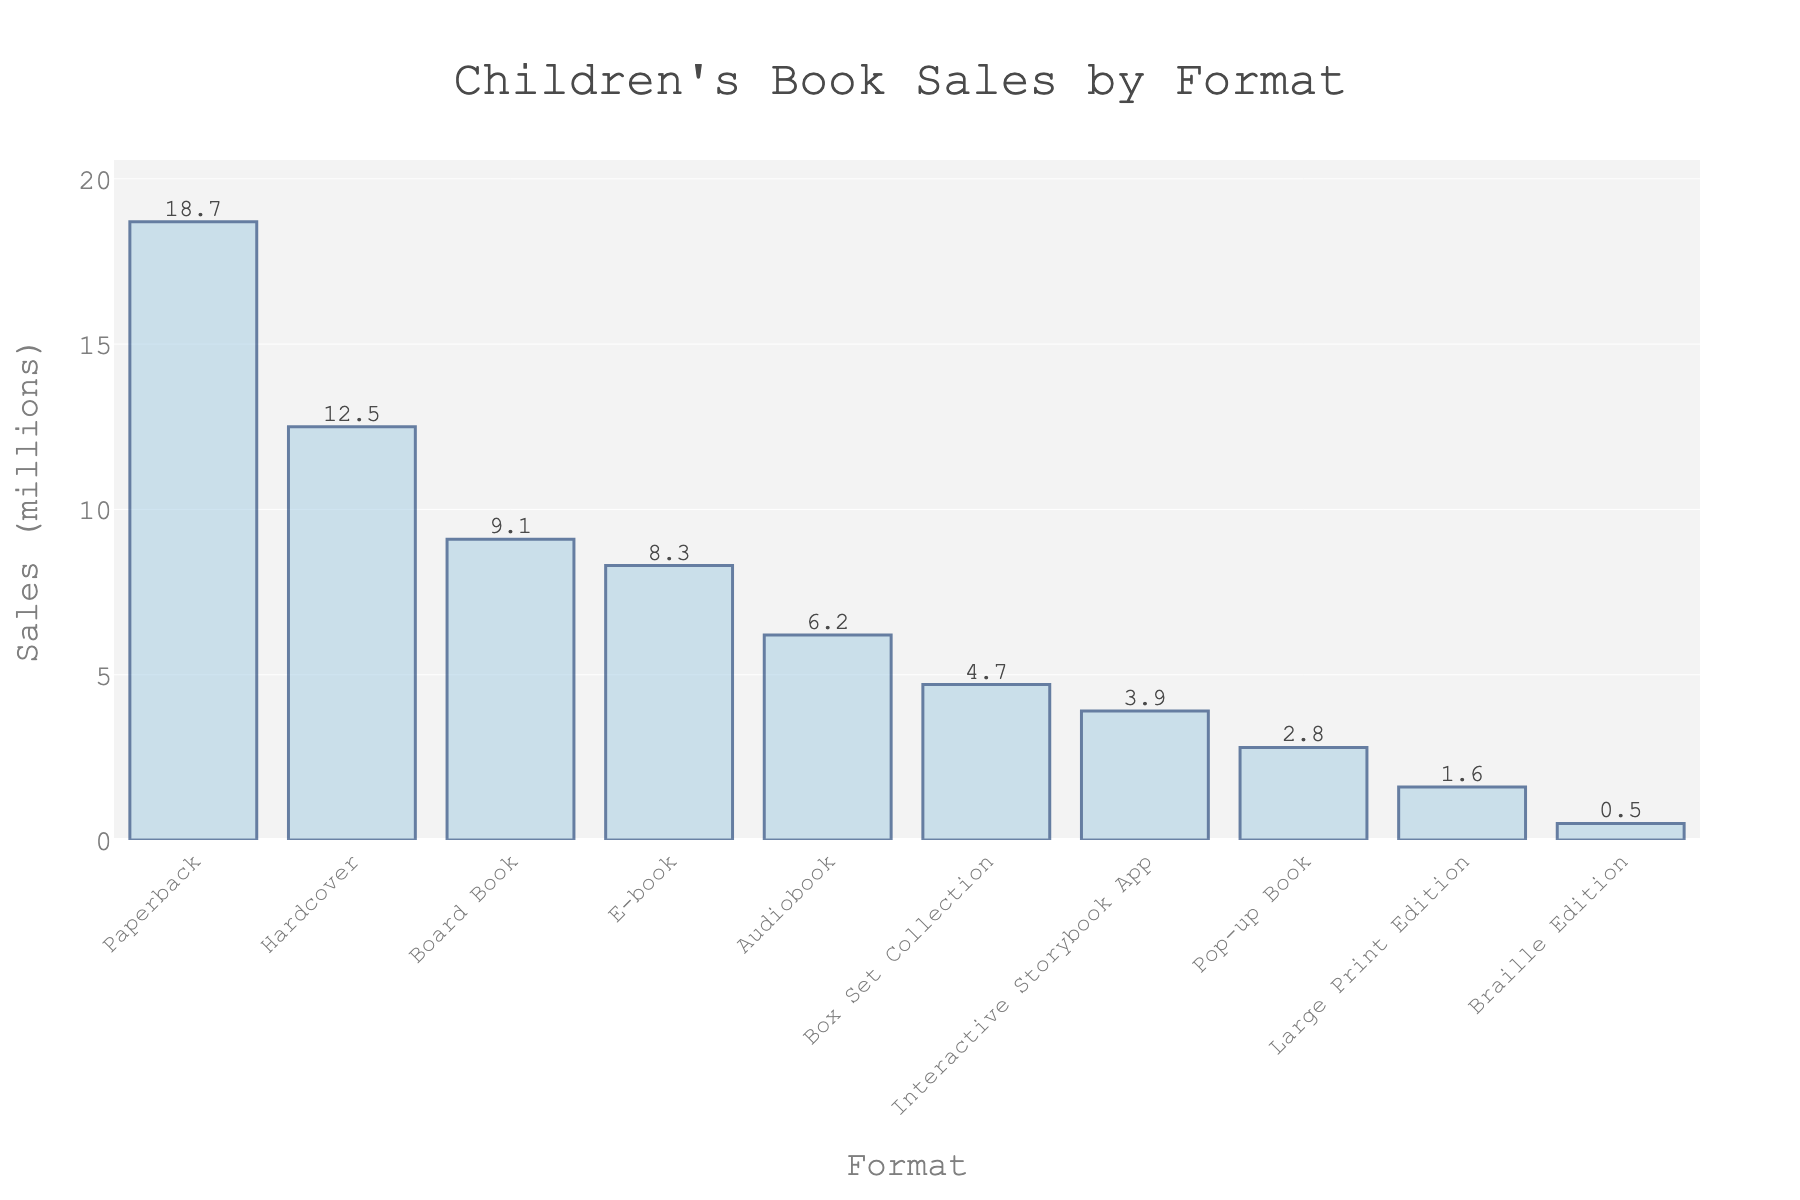Which book format has the highest sales? Look at the bar chart and identify the bar with the greatest height. The Paperback format has the highest sales.
Answer: Paperback What's the total sales for E-books and Audiobooks? Add the sales figures for E-books and Audiobooks: 8.3 million (E-books) + 6.2 million (Audiobooks) = 14.5 million.
Answer: 14.5 million How do the sales of Braille Editions compare to Large Print Editions? Check the heights of the bars for Braille Editions and Large Print Editions. The Braille Edition has lower sales (0.5 million) compared to Large Print Editions (1.6 million).
Answer: Braille Editions have lower sales Which formats have lower sales than Board Books? Identify the bars with heights lower than the Board Book's bar (9.1 million): Interactive Storybook App (3.9 million), Pop-up Book (2.8 million), Large Print Edition (1.6 million), Braille Edition (0.5 million), and Box Set Collection (4.7 million).
Answer: Interactive Storybook App, Pop-up Book, Large Print Edition, Braille Edition, Box Set Collection What's the combined sales for Pop-up Books and Interactive Storybook Apps? Sum the sales figures for Pop-up Books and Interactive Storybook Apps: 2.8 million (Pop-up Books) + 3.9 million (Interactive Storybook Apps) = 6.7 million.
Answer: 6.7 million Which format has the lowest sales? Find the shortest bar. The Braille Edition format has the lowest sales.
Answer: Braille Edition Rank the book formats based on their sales from highest to lowest List the formats in descending order of their bar heights: Paperback, Hardcover, Board Book, E-book, Audiobook, Box Set Collection, Interactive Storybook App, Pop-up Book, Large Print Edition, Braille Edition.
Answer: Paperback, Hardcover, Board Book, E-book, Audiobook, Box Set Collection, Interactive Storybook App, Pop-up Book, Large Print Edition, Braille Edition How much higher are the sales of Paperback compared to Hardcover? Subtract the sales of Hardcover from Paperback to get the difference: 18.7 million - 12.5 million = 6.2 million.
Answer: 6.2 million What is the average sales figure for all formats? Add the sales of all formats and divide by the number of formats: (12.5 + 18.7 + 8.3 + 6.2 + 3.9 + 9.1 + 2.8 + 1.6 + 0.5 + 4.7) / 10 = 68.3 / 10 = 6.83 million.
Answer: 6.83 million 